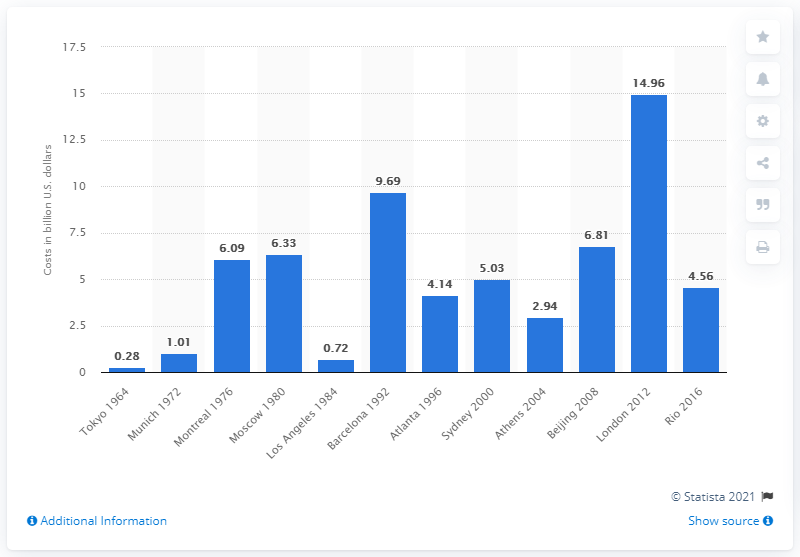Indicate a few pertinent items in this graphic. According to the projected outturn sports-related costs of the 2016 Rio Summer Olympic Games, the costs were estimated to be approximately 4.56 billion dollars. 